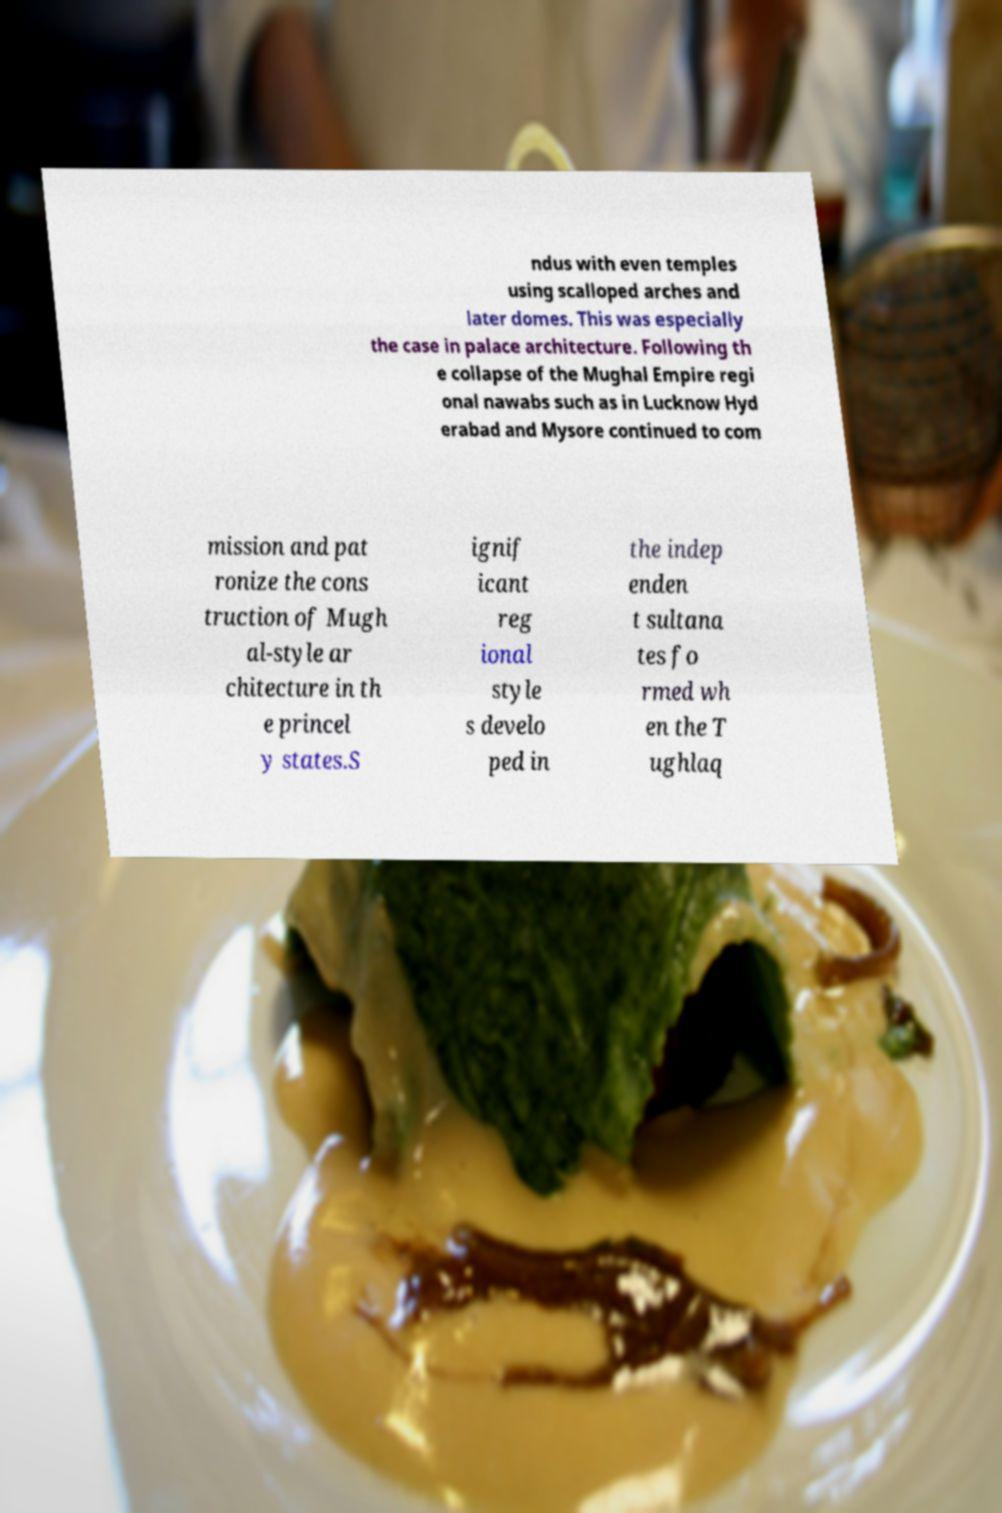Could you assist in decoding the text presented in this image and type it out clearly? ndus with even temples using scalloped arches and later domes. This was especially the case in palace architecture. Following th e collapse of the Mughal Empire regi onal nawabs such as in Lucknow Hyd erabad and Mysore continued to com mission and pat ronize the cons truction of Mugh al-style ar chitecture in th e princel y states.S ignif icant reg ional style s develo ped in the indep enden t sultana tes fo rmed wh en the T ughlaq 